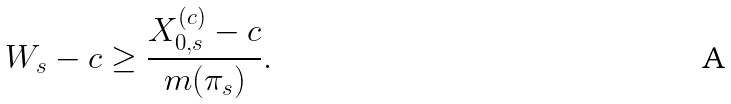Convert formula to latex. <formula><loc_0><loc_0><loc_500><loc_500>W _ { s } - c \geq \frac { X ^ { ( c ) } _ { 0 , s } - c } { m ( \pi _ { s } ) } .</formula> 